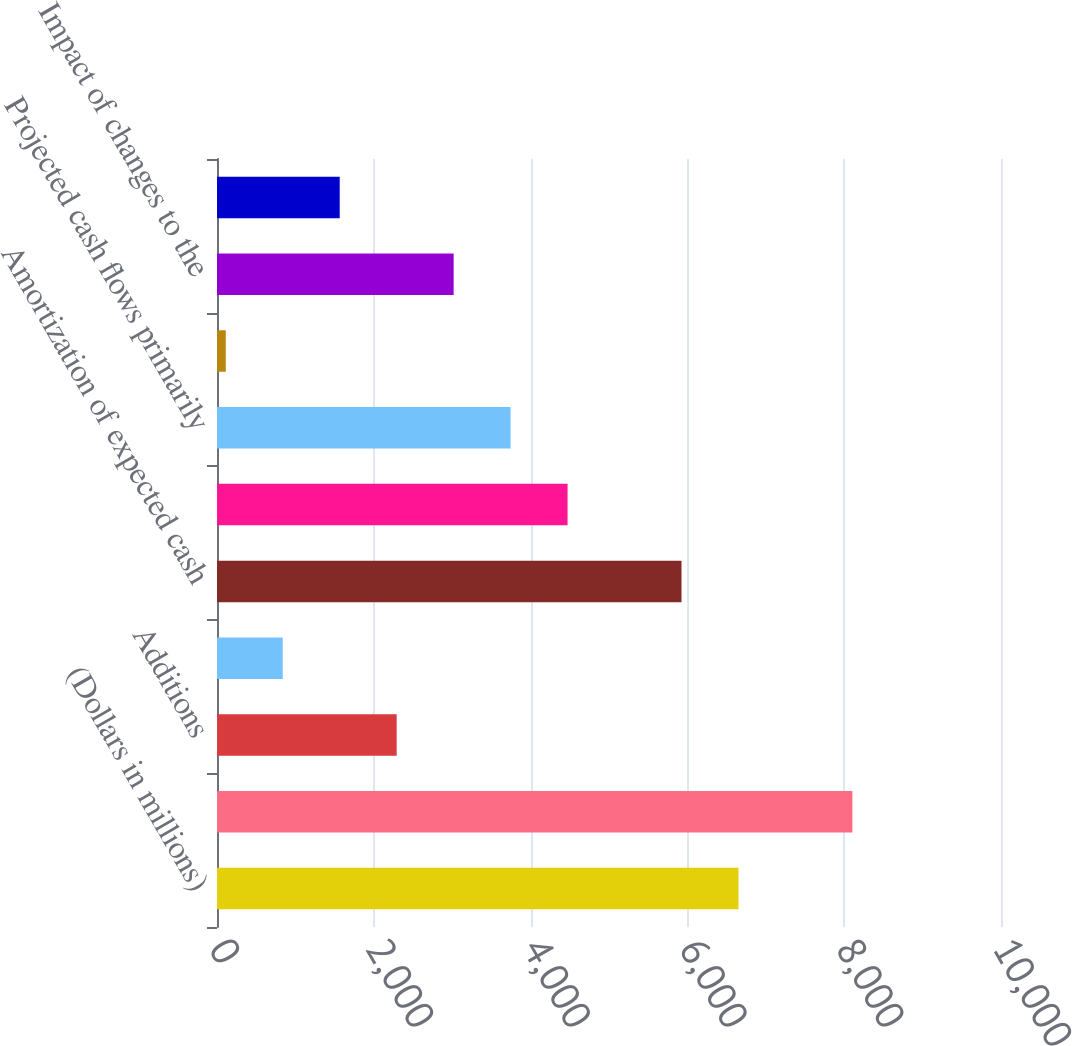<chart> <loc_0><loc_0><loc_500><loc_500><bar_chart><fcel>(Dollars in millions)<fcel>Balance January 1<fcel>Additions<fcel>Sales<fcel>Amortization of expected cash<fcel>Impact of changes in interest<fcel>Projected cash flows primarily<fcel>Impact of changes in the Home<fcel>Impact of changes to the<fcel>Other model changes (4)<nl><fcel>6651.4<fcel>8104.6<fcel>2291.8<fcel>838.6<fcel>5924.8<fcel>4471.6<fcel>3745<fcel>112<fcel>3018.4<fcel>1565.2<nl></chart> 